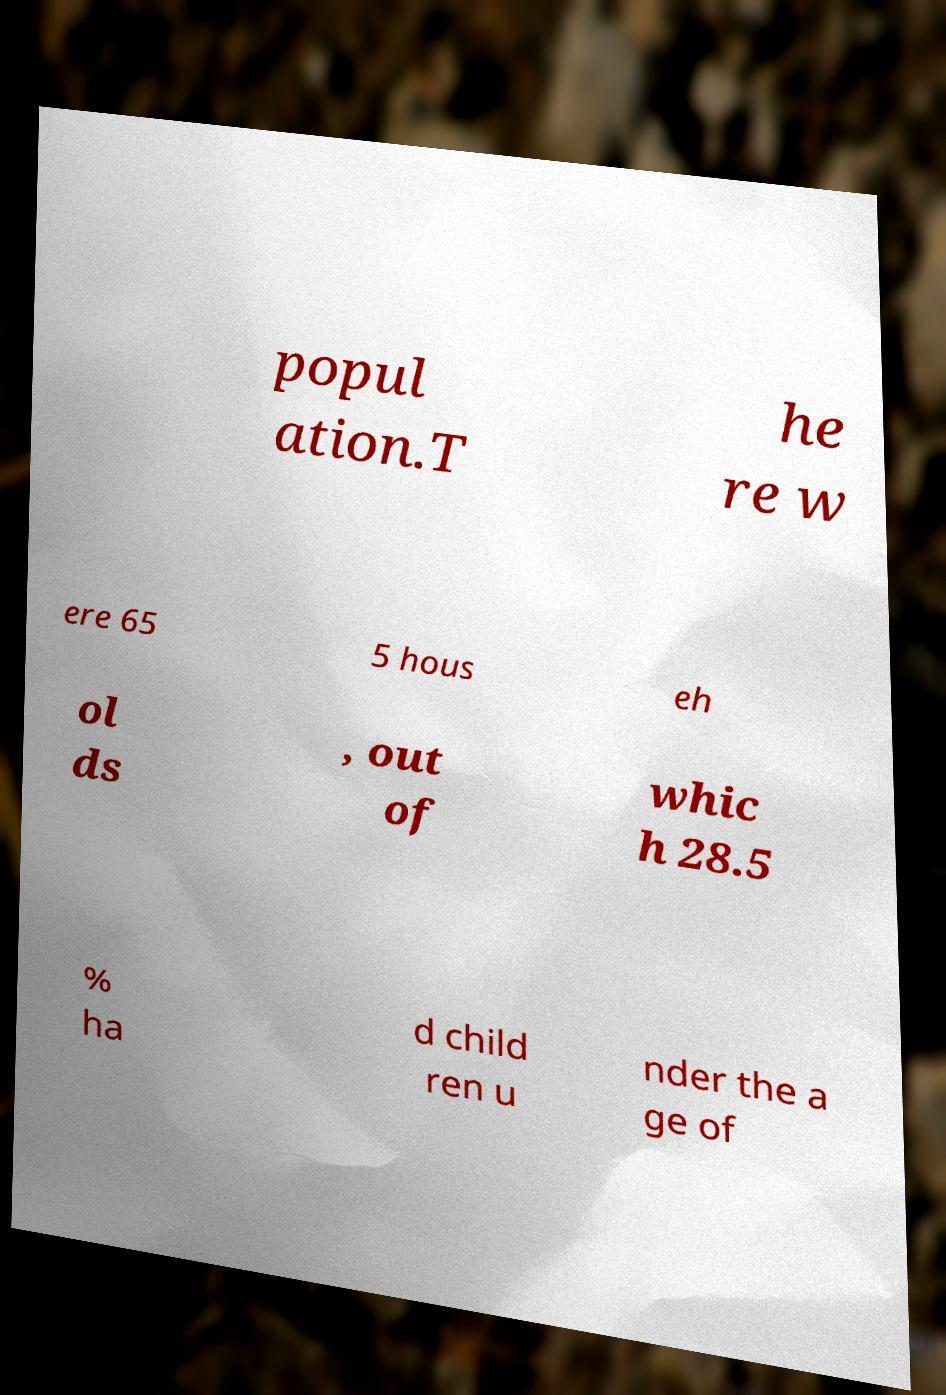Could you extract and type out the text from this image? popul ation.T he re w ere 65 5 hous eh ol ds , out of whic h 28.5 % ha d child ren u nder the a ge of 